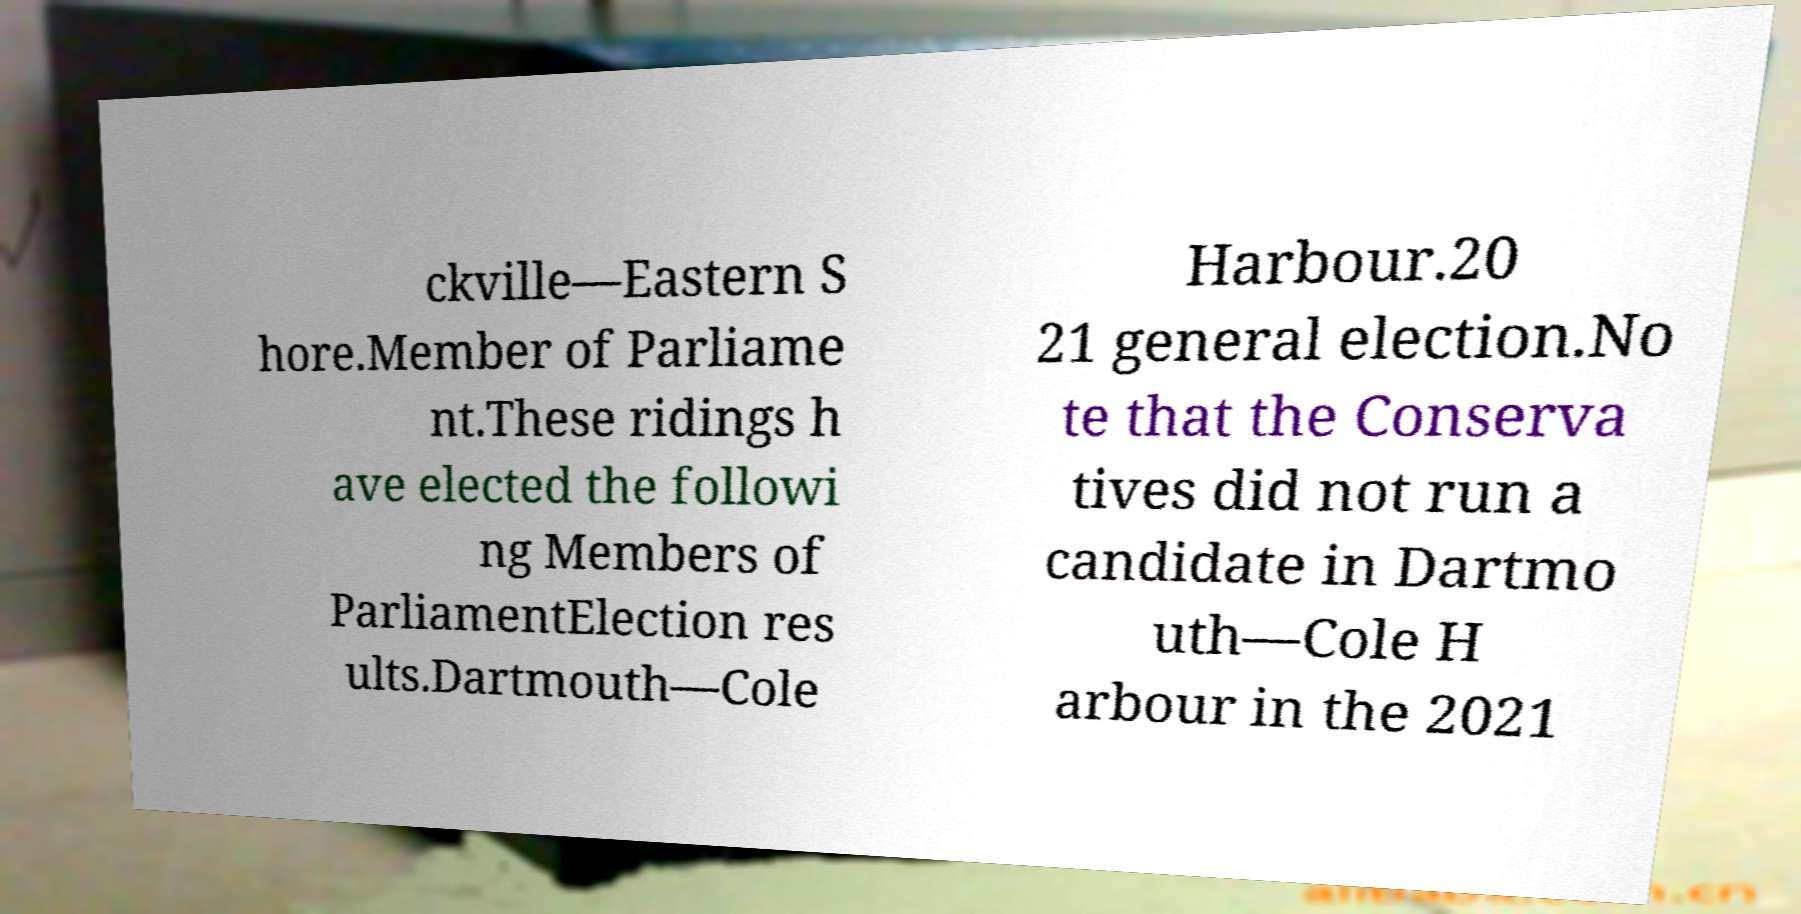Could you extract and type out the text from this image? ckville—Eastern S hore.Member of Parliame nt.These ridings h ave elected the followi ng Members of ParliamentElection res ults.Dartmouth—Cole Harbour.20 21 general election.No te that the Conserva tives did not run a candidate in Dartmo uth—Cole H arbour in the 2021 